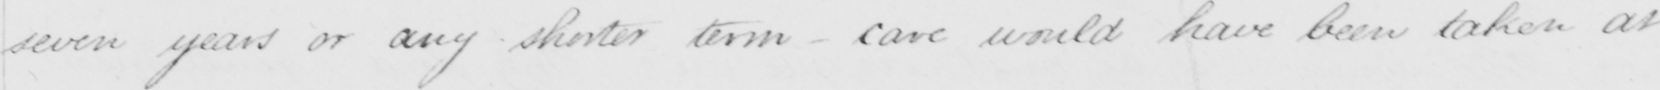What does this handwritten line say? seven years or any shorter term _ care would have been taken at 